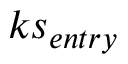<formula> <loc_0><loc_0><loc_500><loc_500>k s _ { e n t r y }</formula> 